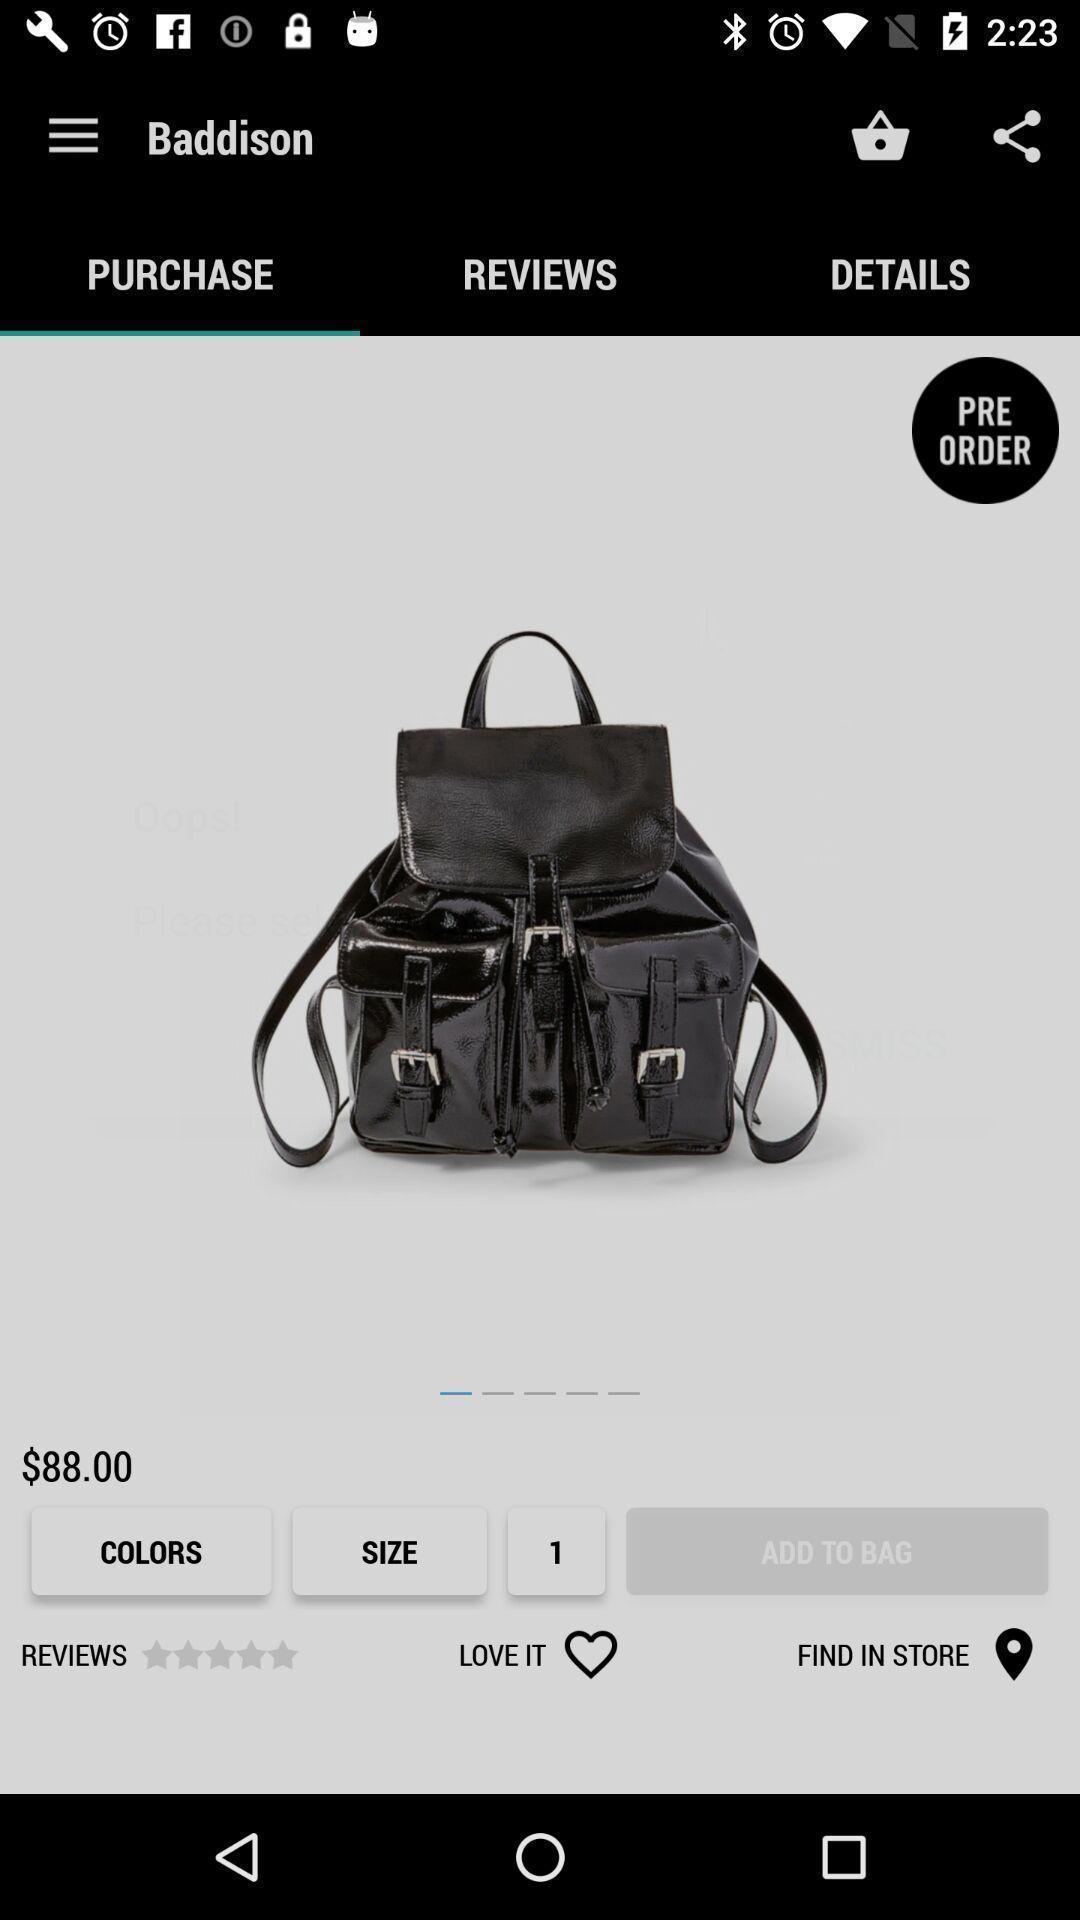Give me a narrative description of this picture. Page displaying for purchasing an item in an shopping application. 